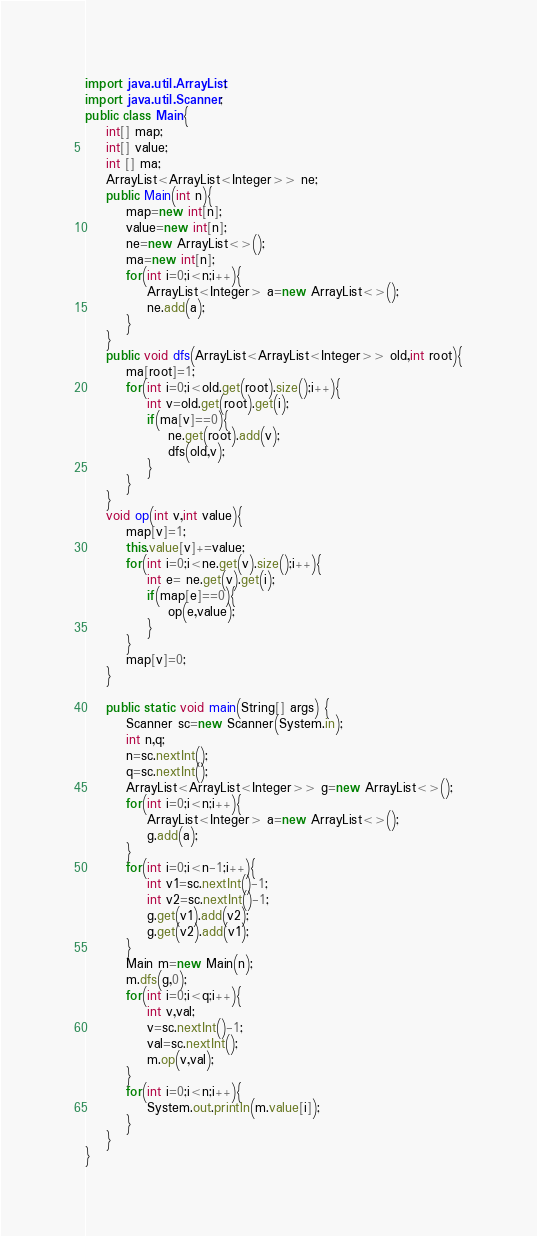<code> <loc_0><loc_0><loc_500><loc_500><_Java_>import java.util.ArrayList;
import java.util.Scanner;
public class Main{
    int[] map;
    int[] value;
    int [] ma;
    ArrayList<ArrayList<Integer>> ne;
    public Main(int n){
        map=new int[n];
        value=new int[n];
        ne=new ArrayList<>();
        ma=new int[n];
        for(int i=0;i<n;i++){
            ArrayList<Integer> a=new ArrayList<>();
            ne.add(a);
        }
    }
    public void dfs(ArrayList<ArrayList<Integer>> old,int root){
        ma[root]=1;
        for(int i=0;i<old.get(root).size();i++){
            int v=old.get(root).get(i);
            if(ma[v]==0){
                ne.get(root).add(v);
                dfs(old,v);
            }
        }
    }
    void op(int v,int value){
        map[v]=1;
        this.value[v]+=value;
        for(int i=0;i<ne.get(v).size();i++){
            int e= ne.get(v).get(i);
            if(map[e]==0){
                op(e,value);
            }
        }
        map[v]=0;
    }

    public static void main(String[] args) {
        Scanner sc=new Scanner(System.in);
        int n,q;
        n=sc.nextInt();
        q=sc.nextInt();
        ArrayList<ArrayList<Integer>> g=new ArrayList<>();
        for(int i=0;i<n;i++){
            ArrayList<Integer> a=new ArrayList<>();
            g.add(a);
        }
        for(int i=0;i<n-1;i++){
            int v1=sc.nextInt()-1;
            int v2=sc.nextInt()-1;
            g.get(v1).add(v2);
            g.get(v2).add(v1);
        }
        Main m=new Main(n);
        m.dfs(g,0);
        for(int i=0;i<q;i++){
            int v,val;
            v=sc.nextInt()-1;
            val=sc.nextInt();
            m.op(v,val);
        }
        for(int i=0;i<n;i++){
            System.out.println(m.value[i]);
        }
    }
}
</code> 